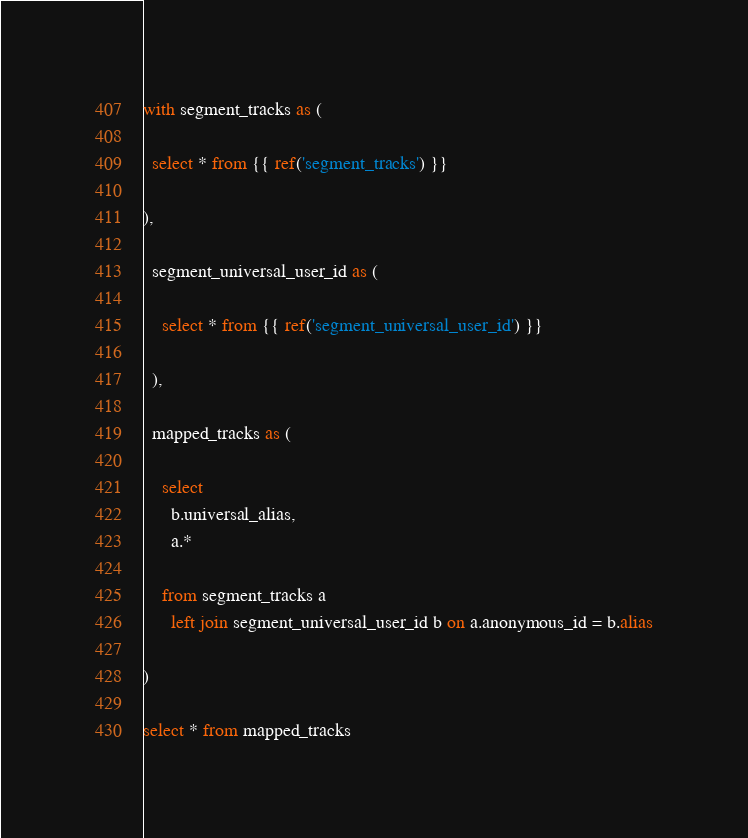Convert code to text. <code><loc_0><loc_0><loc_500><loc_500><_SQL_>with segment_tracks as (

  select * from {{ ref('segment_tracks') }}

),

  segment_universal_user_id as (

    select * from {{ ref('segment_universal_user_id') }}

  ),

  mapped_tracks as (

    select
      b.universal_alias,
      a.*

    from segment_tracks a
      left join segment_universal_user_id b on a.anonymous_id = b.alias

)

select * from mapped_tracks
</code> 